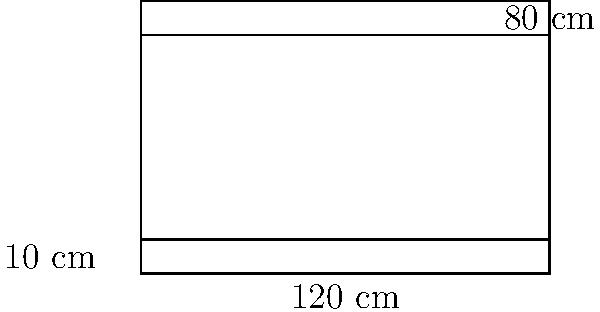As a chess instructor, you're designing a custom rectangular chess table for your virtual lesson studio. The table's dimensions are 120 cm long, 80 cm wide, and 10 cm thick. Calculate the total surface area of the table, including all sides and the top and bottom surfaces. Let's break this down step-by-step:

1) First, we need to identify all the surfaces:
   - Top and bottom (2 identical rectangles)
   - Front and back (2 identical rectangles)
   - Left and right sides (2 identical rectangles)

2) Calculate the area of the top (and bottom):
   $A_{top} = 120 \text{ cm} \times 80 \text{ cm} = 9600 \text{ cm}^2$

3) Calculate the area of the front (and back):
   $A_{front} = 120 \text{ cm} \times 10 \text{ cm} = 1200 \text{ cm}^2$

4) Calculate the area of the side:
   $A_{side} = 80 \text{ cm} \times 10 \text{ cm} = 800 \text{ cm}^2$

5) Now, sum up all the areas:
   - Top and bottom: $9600 \text{ cm}^2 \times 2 = 19200 \text{ cm}^2$
   - Front and back: $1200 \text{ cm}^2 \times 2 = 2400 \text{ cm}^2$
   - Left and right sides: $800 \text{ cm}^2 \times 2 = 1600 \text{ cm}^2$

6) Total surface area:
   $A_{total} = 19200 + 2400 + 1600 = 23200 \text{ cm}^2$

Therefore, the total surface area of the chess table is 23200 cm².
Answer: 23200 cm² 